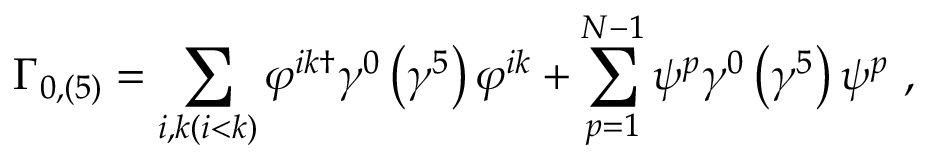<formula> <loc_0><loc_0><loc_500><loc_500>\Gamma _ { 0 , \left ( 5 \right ) } = \sum _ { i , k ( i < k ) } \varphi ^ { i k \dagger } \gamma ^ { 0 } \left ( \gamma ^ { 5 } \right ) \varphi ^ { i k } + \sum _ { p = 1 } ^ { N - 1 } \psi ^ { p } \gamma ^ { 0 } \left ( \gamma ^ { 5 } \right ) \psi ^ { p } \ ,</formula> 